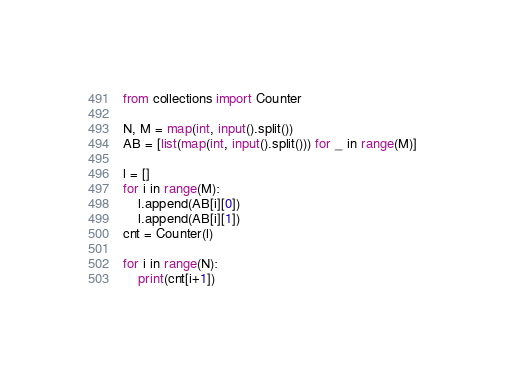<code> <loc_0><loc_0><loc_500><loc_500><_Python_>from collections import Counter

N, M = map(int, input().split())
AB = [list(map(int, input().split())) for _ in range(M)]

l = []
for i in range(M):
    l.append(AB[i][0])
    l.append(AB[i][1])
cnt = Counter(l)

for i in range(N):
    print(cnt[i+1])</code> 